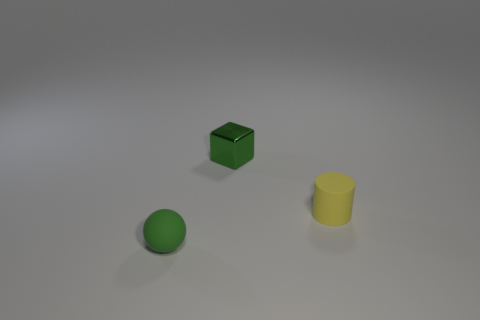Is the size of the yellow cylinder the same as the green object on the right side of the small sphere?
Your response must be concise. Yes. How many yellow objects are either cylinders or shiny cubes?
Provide a short and direct response. 1. How many large green matte cylinders are there?
Provide a short and direct response. 0. What size is the thing in front of the yellow cylinder?
Make the answer very short. Small. Does the yellow rubber thing have the same size as the green block?
Your answer should be compact. Yes. How many objects are small blue metallic cylinders or green things behind the yellow rubber object?
Make the answer very short. 1. What material is the tiny sphere?
Provide a succinct answer. Rubber. Is there any other thing that is the same color as the small metal block?
Offer a terse response. Yes. Does the tiny green rubber thing have the same shape as the small yellow object?
Your answer should be very brief. No. How big is the rubber object that is in front of the rubber thing on the right side of the tiny rubber thing on the left side of the tiny green metal cube?
Give a very brief answer. Small. 